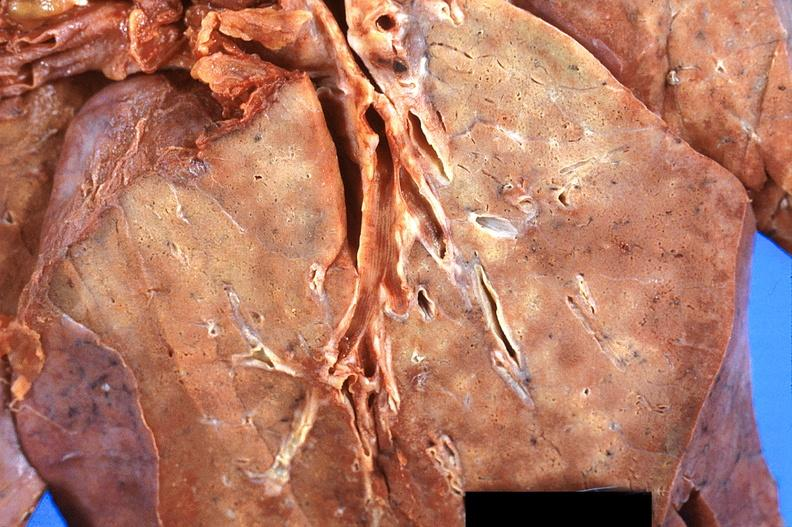what is present?
Answer the question using a single word or phrase. Respiratory 